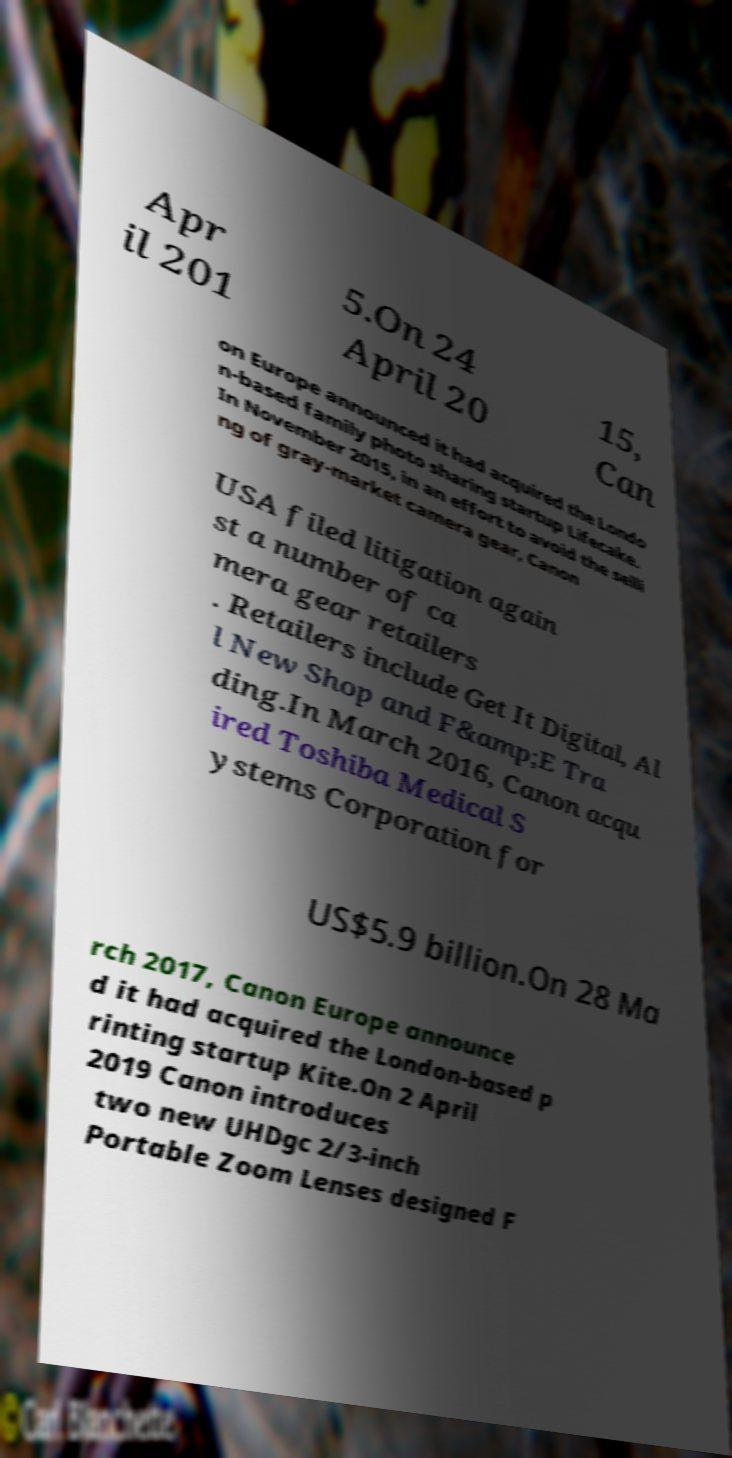For documentation purposes, I need the text within this image transcribed. Could you provide that? Apr il 201 5.On 24 April 20 15, Can on Europe announced it had acquired the Londo n-based family photo sharing startup Lifecake. In November 2015, in an effort to avoid the selli ng of gray-market camera gear, Canon USA filed litigation again st a number of ca mera gear retailers . Retailers include Get It Digital, Al l New Shop and F&amp;E Tra ding.In March 2016, Canon acqu ired Toshiba Medical S ystems Corporation for US$5.9 billion.On 28 Ma rch 2017, Canon Europe announce d it had acquired the London-based p rinting startup Kite.On 2 April 2019 Canon introduces two new UHDgc 2/3-inch Portable Zoom Lenses designed F 